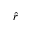<formula> <loc_0><loc_0><loc_500><loc_500>\hat { r }</formula> 